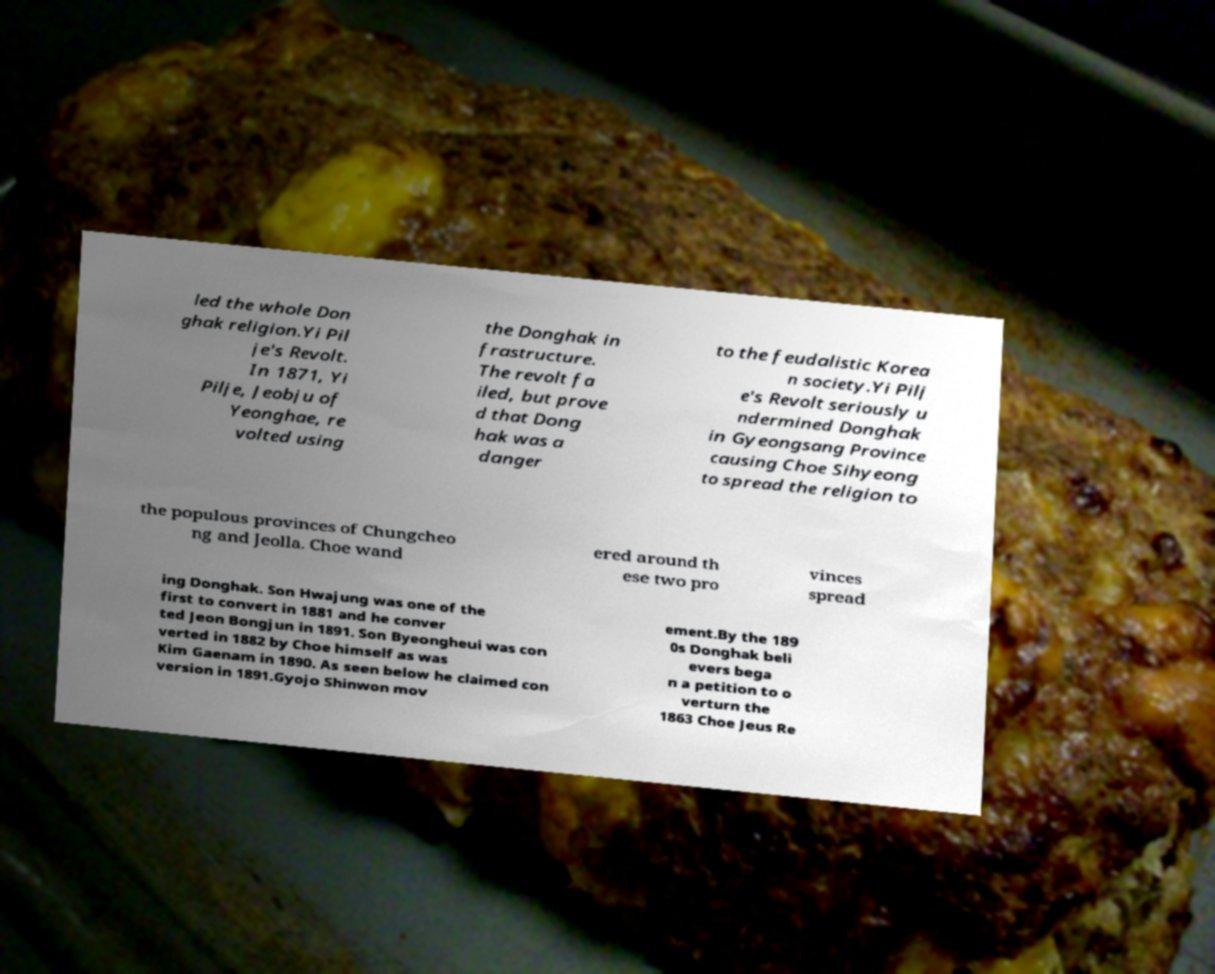Please read and relay the text visible in this image. What does it say? led the whole Don ghak religion.Yi Pil je's Revolt. In 1871, Yi Pilje, Jeobju of Yeonghae, re volted using the Donghak in frastructure. The revolt fa iled, but prove d that Dong hak was a danger to the feudalistic Korea n society.Yi Pilj e's Revolt seriously u ndermined Donghak in Gyeongsang Province causing Choe Sihyeong to spread the religion to the populous provinces of Chungcheo ng and Jeolla. Choe wand ered around th ese two pro vinces spread ing Donghak. Son Hwajung was one of the first to convert in 1881 and he conver ted Jeon Bongjun in 1891. Son Byeongheui was con verted in 1882 by Choe himself as was Kim Gaenam in 1890. As seen below he claimed con version in 1891.Gyojo Shinwon mov ement.By the 189 0s Donghak beli evers bega n a petition to o verturn the 1863 Choe Jeus Re 